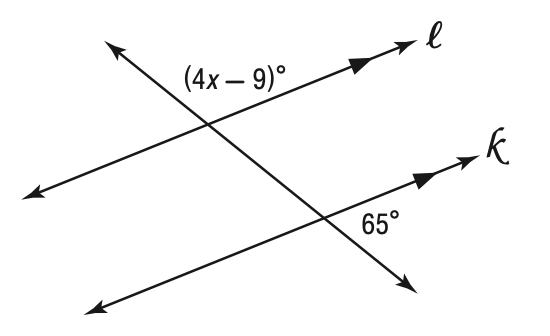Question: Solve for x in the figure below.
Choices:
A. 31
B. 59
C. 65
D. 115
Answer with the letter. Answer: A 